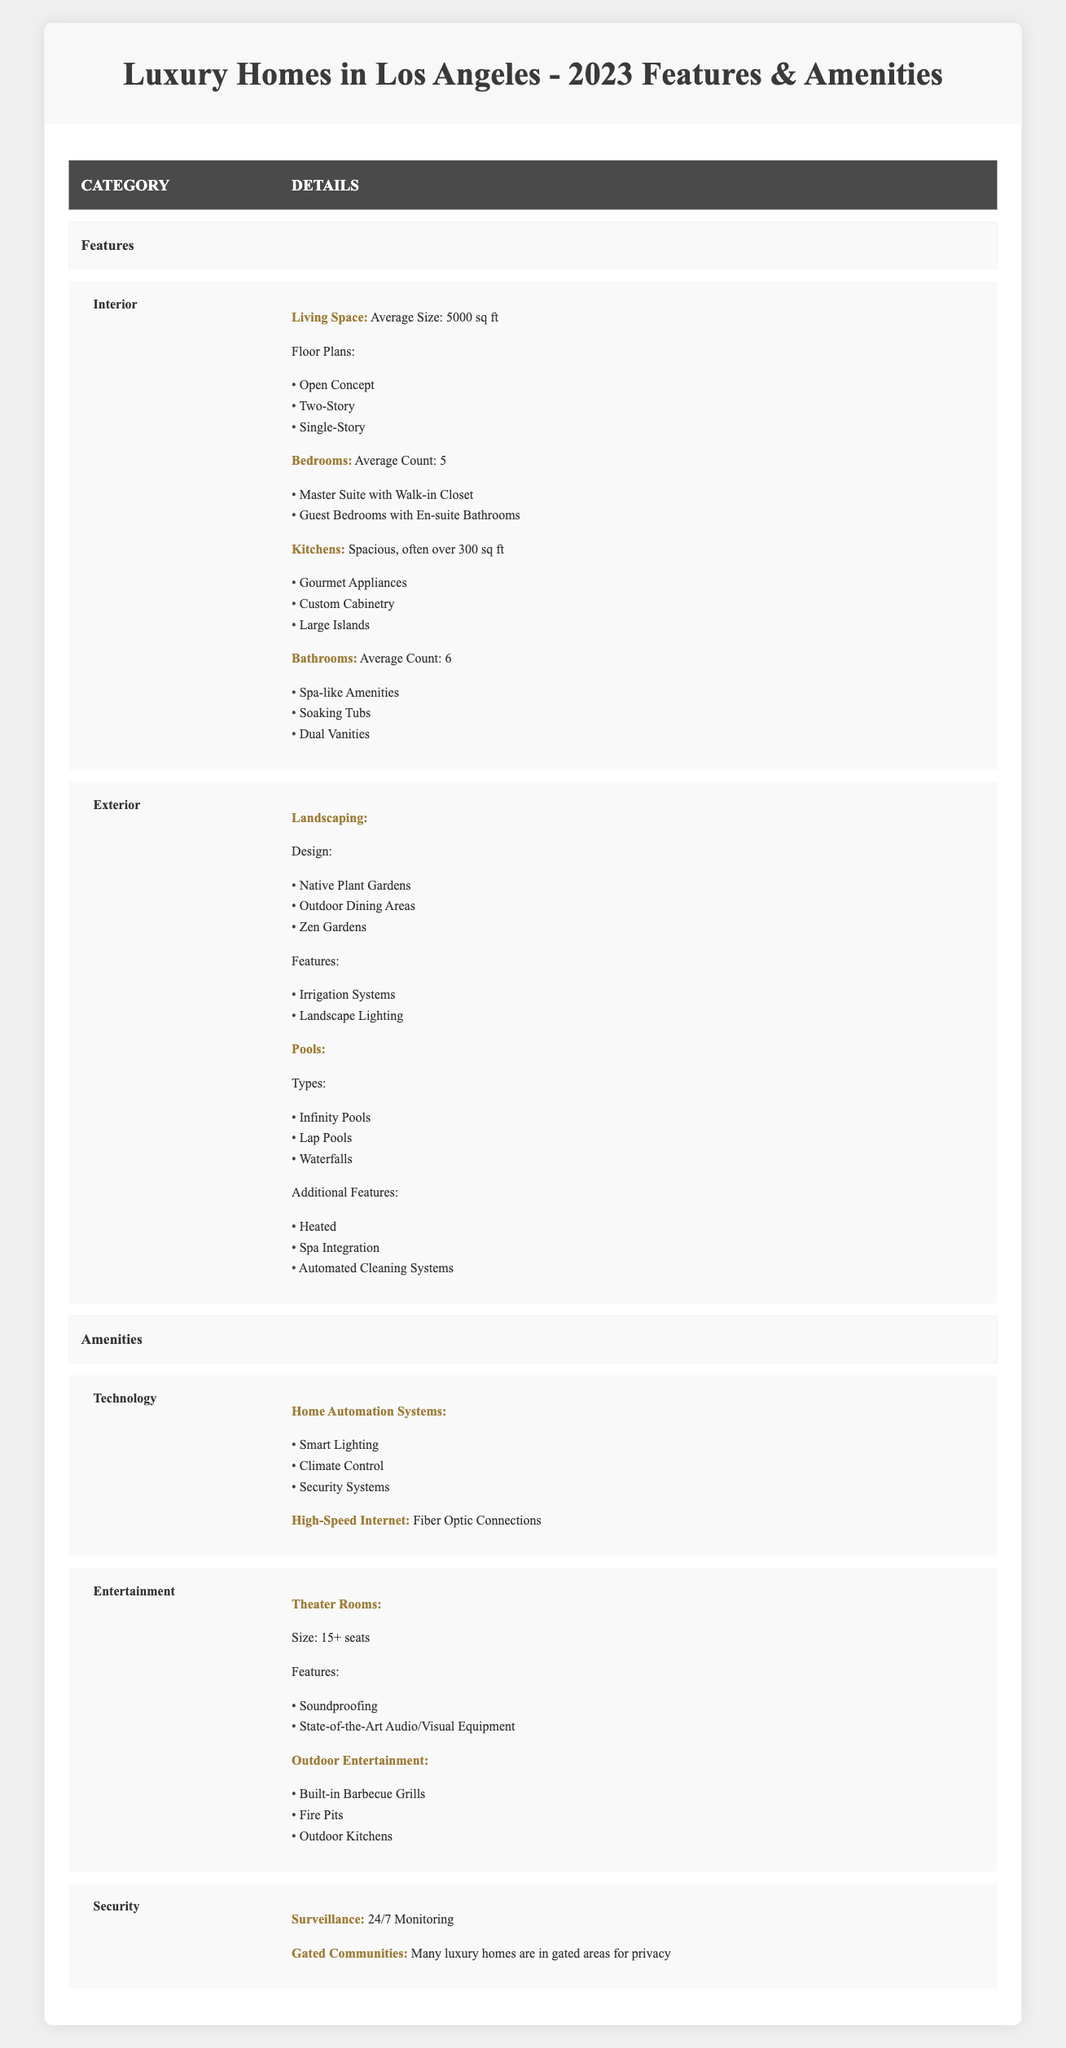What is the average size of living space in luxury homes? According to the table, the average size of living space is listed as 5000 sq ft. This value is directly retrievable from the row labeled "Living Space" under "Interior Features."
Answer: 5000 sq ft How many bedrooms do luxury homes typically have on average? The table states that the average count of bedrooms in luxury homes is 5, which can be found under the "Bedrooms" section of the "Interior Features."
Answer: 5 Are there any luxury homes with pools that include waterfalls? Yes, the table mentions that waterfalls are one of the types of pools available in luxury homes, as shown in the "Pools" section under "Exterior Features."
Answer: Yes What is the average number of bathrooms in these luxury homes? The average number of bathrooms is stated as 6 in the "Bathrooms" row under "Interior Features." This is a straightforward retrieval question.
Answer: 6 How many floor plans are available for luxury homes? The table lists three floor plans under the "Living Space" section: Open Concept, Two-Story, and Single-Story. Therefore, the total is 3.
Answer: 3 Do luxury homes in Los Angeles have 24/7 surveillance systems? Yes, the table confirms that luxury homes have 24/7 surveillance monitoring under the "Security" section.
Answer: Yes What are the additional features typically included with pools? The additional features for pools listed in the table include Heating, Spa Integration, and Automated Cleaning Systems. These are all mentioned in the "Additional Features" section under "Pools."
Answer: Heated, Spa Integration, Automated Cleaning Systems If a house has an outdoor kitchen, how many seats would its theater room likely have? Based on the table, outdoor entertainment includes features like outdoor kitchens, and theater rooms typically have 15 or more seats. Therefore, if a house has an outdoor kitchen, its theater room would likely accommodate 15+ seats.
Answer: 15+ seats What percentage of bedrooms in luxury homes have en-suite bathrooms? From the data, there are 5 average bedrooms, and the table indicates that guest bedrooms come with en-suite bathrooms, but no exact percentage is provided. Therefore, an accurate percentage cannot be calculated with this information alone.
Answer: Not calculable based on provided data 